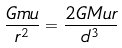Convert formula to latex. <formula><loc_0><loc_0><loc_500><loc_500>\frac { G m u } { r ^ { 2 } } = \frac { 2 G M u r } { d ^ { 3 } }</formula> 